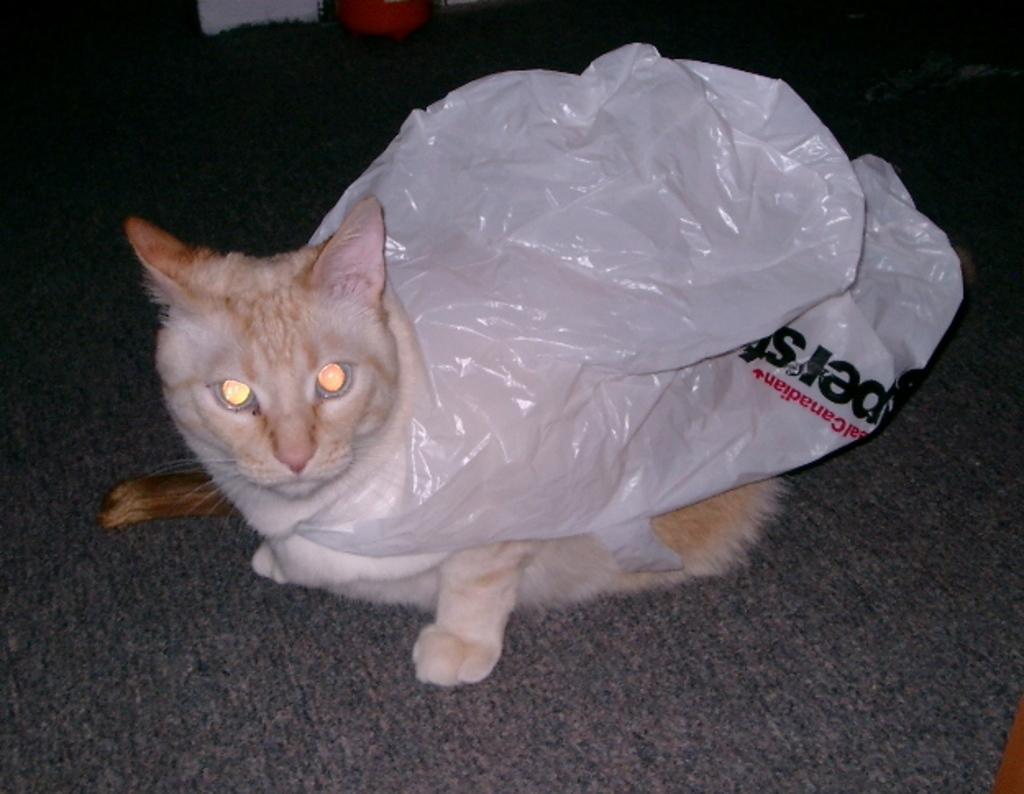In one or two sentences, can you explain what this image depicts? In this image, we can see a cat on the carpet, we can see a plastic cover on the cat. 